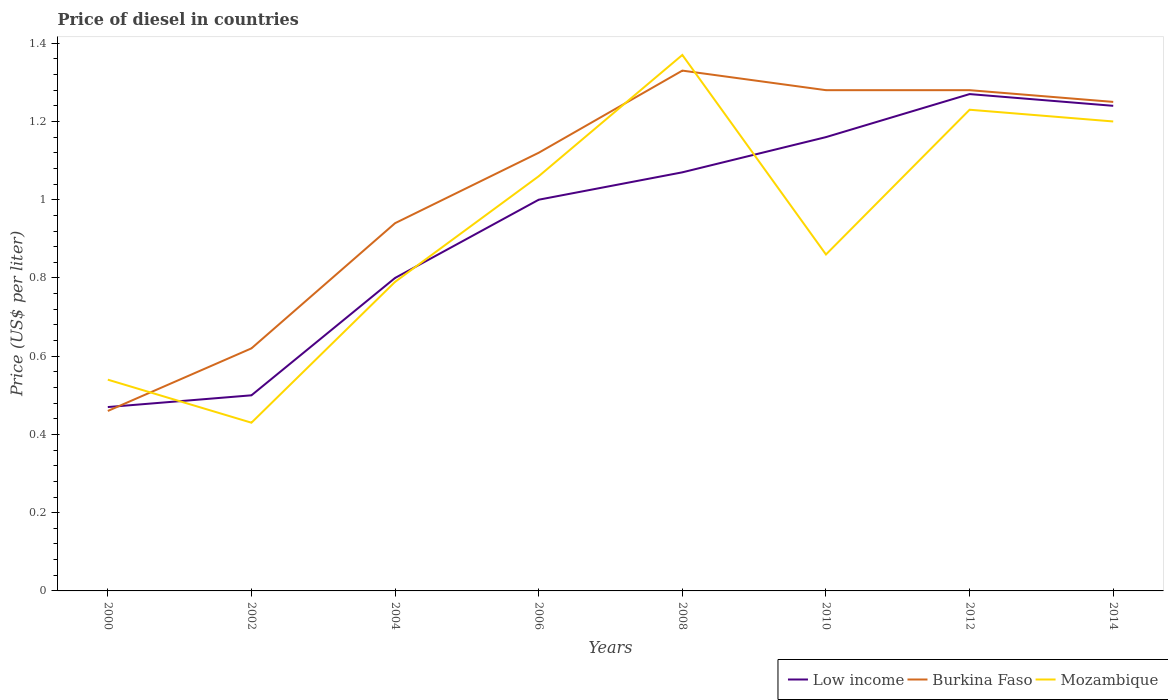How many different coloured lines are there?
Keep it short and to the point. 3. Does the line corresponding to Low income intersect with the line corresponding to Mozambique?
Your answer should be compact. Yes. Is the number of lines equal to the number of legend labels?
Your answer should be very brief. Yes. Across all years, what is the maximum price of diesel in Low income?
Provide a short and direct response. 0.47. In which year was the price of diesel in Low income maximum?
Your answer should be very brief. 2000. What is the difference between the highest and the second highest price of diesel in Mozambique?
Ensure brevity in your answer.  0.94. Is the price of diesel in Burkina Faso strictly greater than the price of diesel in Mozambique over the years?
Your response must be concise. No. How many lines are there?
Your answer should be compact. 3. What is the difference between two consecutive major ticks on the Y-axis?
Provide a succinct answer. 0.2. Does the graph contain any zero values?
Give a very brief answer. No. How many legend labels are there?
Your answer should be very brief. 3. How are the legend labels stacked?
Your answer should be compact. Horizontal. What is the title of the graph?
Provide a succinct answer. Price of diesel in countries. What is the label or title of the Y-axis?
Ensure brevity in your answer.  Price (US$ per liter). What is the Price (US$ per liter) of Low income in 2000?
Ensure brevity in your answer.  0.47. What is the Price (US$ per liter) in Burkina Faso in 2000?
Your response must be concise. 0.46. What is the Price (US$ per liter) in Mozambique in 2000?
Give a very brief answer. 0.54. What is the Price (US$ per liter) of Burkina Faso in 2002?
Give a very brief answer. 0.62. What is the Price (US$ per liter) of Mozambique in 2002?
Offer a very short reply. 0.43. What is the Price (US$ per liter) of Mozambique in 2004?
Offer a very short reply. 0.79. What is the Price (US$ per liter) of Burkina Faso in 2006?
Provide a succinct answer. 1.12. What is the Price (US$ per liter) of Mozambique in 2006?
Your answer should be compact. 1.06. What is the Price (US$ per liter) of Low income in 2008?
Offer a very short reply. 1.07. What is the Price (US$ per liter) of Burkina Faso in 2008?
Your response must be concise. 1.33. What is the Price (US$ per liter) of Mozambique in 2008?
Give a very brief answer. 1.37. What is the Price (US$ per liter) of Low income in 2010?
Keep it short and to the point. 1.16. What is the Price (US$ per liter) of Burkina Faso in 2010?
Keep it short and to the point. 1.28. What is the Price (US$ per liter) in Mozambique in 2010?
Give a very brief answer. 0.86. What is the Price (US$ per liter) in Low income in 2012?
Your answer should be compact. 1.27. What is the Price (US$ per liter) of Burkina Faso in 2012?
Provide a short and direct response. 1.28. What is the Price (US$ per liter) in Mozambique in 2012?
Provide a short and direct response. 1.23. What is the Price (US$ per liter) of Low income in 2014?
Offer a very short reply. 1.24. What is the Price (US$ per liter) in Burkina Faso in 2014?
Offer a very short reply. 1.25. What is the Price (US$ per liter) in Mozambique in 2014?
Your response must be concise. 1.2. Across all years, what is the maximum Price (US$ per liter) of Low income?
Keep it short and to the point. 1.27. Across all years, what is the maximum Price (US$ per liter) in Burkina Faso?
Your answer should be compact. 1.33. Across all years, what is the maximum Price (US$ per liter) of Mozambique?
Give a very brief answer. 1.37. Across all years, what is the minimum Price (US$ per liter) of Low income?
Offer a terse response. 0.47. Across all years, what is the minimum Price (US$ per liter) in Burkina Faso?
Provide a succinct answer. 0.46. Across all years, what is the minimum Price (US$ per liter) in Mozambique?
Keep it short and to the point. 0.43. What is the total Price (US$ per liter) of Low income in the graph?
Your response must be concise. 7.51. What is the total Price (US$ per liter) in Burkina Faso in the graph?
Give a very brief answer. 8.28. What is the total Price (US$ per liter) in Mozambique in the graph?
Keep it short and to the point. 7.48. What is the difference between the Price (US$ per liter) of Low income in 2000 and that in 2002?
Your response must be concise. -0.03. What is the difference between the Price (US$ per liter) of Burkina Faso in 2000 and that in 2002?
Offer a terse response. -0.16. What is the difference between the Price (US$ per liter) in Mozambique in 2000 and that in 2002?
Make the answer very short. 0.11. What is the difference between the Price (US$ per liter) in Low income in 2000 and that in 2004?
Provide a succinct answer. -0.33. What is the difference between the Price (US$ per liter) in Burkina Faso in 2000 and that in 2004?
Your answer should be very brief. -0.48. What is the difference between the Price (US$ per liter) of Mozambique in 2000 and that in 2004?
Make the answer very short. -0.25. What is the difference between the Price (US$ per liter) of Low income in 2000 and that in 2006?
Provide a succinct answer. -0.53. What is the difference between the Price (US$ per liter) of Burkina Faso in 2000 and that in 2006?
Offer a terse response. -0.66. What is the difference between the Price (US$ per liter) in Mozambique in 2000 and that in 2006?
Offer a very short reply. -0.52. What is the difference between the Price (US$ per liter) in Low income in 2000 and that in 2008?
Keep it short and to the point. -0.6. What is the difference between the Price (US$ per liter) of Burkina Faso in 2000 and that in 2008?
Your response must be concise. -0.87. What is the difference between the Price (US$ per liter) of Mozambique in 2000 and that in 2008?
Your response must be concise. -0.83. What is the difference between the Price (US$ per liter) in Low income in 2000 and that in 2010?
Offer a very short reply. -0.69. What is the difference between the Price (US$ per liter) of Burkina Faso in 2000 and that in 2010?
Your answer should be compact. -0.82. What is the difference between the Price (US$ per liter) of Mozambique in 2000 and that in 2010?
Your response must be concise. -0.32. What is the difference between the Price (US$ per liter) of Burkina Faso in 2000 and that in 2012?
Offer a very short reply. -0.82. What is the difference between the Price (US$ per liter) of Mozambique in 2000 and that in 2012?
Your answer should be compact. -0.69. What is the difference between the Price (US$ per liter) in Low income in 2000 and that in 2014?
Offer a very short reply. -0.77. What is the difference between the Price (US$ per liter) in Burkina Faso in 2000 and that in 2014?
Your answer should be compact. -0.79. What is the difference between the Price (US$ per liter) of Mozambique in 2000 and that in 2014?
Provide a succinct answer. -0.66. What is the difference between the Price (US$ per liter) of Low income in 2002 and that in 2004?
Make the answer very short. -0.3. What is the difference between the Price (US$ per liter) of Burkina Faso in 2002 and that in 2004?
Give a very brief answer. -0.32. What is the difference between the Price (US$ per liter) of Mozambique in 2002 and that in 2004?
Your answer should be very brief. -0.36. What is the difference between the Price (US$ per liter) of Burkina Faso in 2002 and that in 2006?
Your response must be concise. -0.5. What is the difference between the Price (US$ per liter) in Mozambique in 2002 and that in 2006?
Your answer should be compact. -0.63. What is the difference between the Price (US$ per liter) in Low income in 2002 and that in 2008?
Make the answer very short. -0.57. What is the difference between the Price (US$ per liter) in Burkina Faso in 2002 and that in 2008?
Your answer should be very brief. -0.71. What is the difference between the Price (US$ per liter) of Mozambique in 2002 and that in 2008?
Ensure brevity in your answer.  -0.94. What is the difference between the Price (US$ per liter) of Low income in 2002 and that in 2010?
Your answer should be very brief. -0.66. What is the difference between the Price (US$ per liter) of Burkina Faso in 2002 and that in 2010?
Offer a terse response. -0.66. What is the difference between the Price (US$ per liter) in Mozambique in 2002 and that in 2010?
Provide a short and direct response. -0.43. What is the difference between the Price (US$ per liter) in Low income in 2002 and that in 2012?
Your response must be concise. -0.77. What is the difference between the Price (US$ per liter) in Burkina Faso in 2002 and that in 2012?
Provide a short and direct response. -0.66. What is the difference between the Price (US$ per liter) of Low income in 2002 and that in 2014?
Make the answer very short. -0.74. What is the difference between the Price (US$ per liter) of Burkina Faso in 2002 and that in 2014?
Provide a short and direct response. -0.63. What is the difference between the Price (US$ per liter) of Mozambique in 2002 and that in 2014?
Offer a very short reply. -0.77. What is the difference between the Price (US$ per liter) of Burkina Faso in 2004 and that in 2006?
Make the answer very short. -0.18. What is the difference between the Price (US$ per liter) of Mozambique in 2004 and that in 2006?
Ensure brevity in your answer.  -0.27. What is the difference between the Price (US$ per liter) in Low income in 2004 and that in 2008?
Provide a short and direct response. -0.27. What is the difference between the Price (US$ per liter) in Burkina Faso in 2004 and that in 2008?
Provide a succinct answer. -0.39. What is the difference between the Price (US$ per liter) in Mozambique in 2004 and that in 2008?
Give a very brief answer. -0.58. What is the difference between the Price (US$ per liter) in Low income in 2004 and that in 2010?
Your response must be concise. -0.36. What is the difference between the Price (US$ per liter) in Burkina Faso in 2004 and that in 2010?
Provide a short and direct response. -0.34. What is the difference between the Price (US$ per liter) of Mozambique in 2004 and that in 2010?
Provide a succinct answer. -0.07. What is the difference between the Price (US$ per liter) in Low income in 2004 and that in 2012?
Provide a short and direct response. -0.47. What is the difference between the Price (US$ per liter) in Burkina Faso in 2004 and that in 2012?
Ensure brevity in your answer.  -0.34. What is the difference between the Price (US$ per liter) in Mozambique in 2004 and that in 2012?
Ensure brevity in your answer.  -0.44. What is the difference between the Price (US$ per liter) of Low income in 2004 and that in 2014?
Keep it short and to the point. -0.44. What is the difference between the Price (US$ per liter) in Burkina Faso in 2004 and that in 2014?
Your answer should be very brief. -0.31. What is the difference between the Price (US$ per liter) of Mozambique in 2004 and that in 2014?
Your answer should be very brief. -0.41. What is the difference between the Price (US$ per liter) of Low income in 2006 and that in 2008?
Provide a short and direct response. -0.07. What is the difference between the Price (US$ per liter) of Burkina Faso in 2006 and that in 2008?
Provide a succinct answer. -0.21. What is the difference between the Price (US$ per liter) in Mozambique in 2006 and that in 2008?
Your response must be concise. -0.31. What is the difference between the Price (US$ per liter) of Low income in 2006 and that in 2010?
Offer a terse response. -0.16. What is the difference between the Price (US$ per liter) in Burkina Faso in 2006 and that in 2010?
Your response must be concise. -0.16. What is the difference between the Price (US$ per liter) in Low income in 2006 and that in 2012?
Your answer should be compact. -0.27. What is the difference between the Price (US$ per liter) of Burkina Faso in 2006 and that in 2012?
Provide a short and direct response. -0.16. What is the difference between the Price (US$ per liter) in Mozambique in 2006 and that in 2012?
Ensure brevity in your answer.  -0.17. What is the difference between the Price (US$ per liter) of Low income in 2006 and that in 2014?
Give a very brief answer. -0.24. What is the difference between the Price (US$ per liter) of Burkina Faso in 2006 and that in 2014?
Provide a succinct answer. -0.13. What is the difference between the Price (US$ per liter) of Mozambique in 2006 and that in 2014?
Keep it short and to the point. -0.14. What is the difference between the Price (US$ per liter) of Low income in 2008 and that in 2010?
Keep it short and to the point. -0.09. What is the difference between the Price (US$ per liter) of Mozambique in 2008 and that in 2010?
Your response must be concise. 0.51. What is the difference between the Price (US$ per liter) in Burkina Faso in 2008 and that in 2012?
Offer a very short reply. 0.05. What is the difference between the Price (US$ per liter) in Mozambique in 2008 and that in 2012?
Ensure brevity in your answer.  0.14. What is the difference between the Price (US$ per liter) in Low income in 2008 and that in 2014?
Keep it short and to the point. -0.17. What is the difference between the Price (US$ per liter) in Mozambique in 2008 and that in 2014?
Your answer should be very brief. 0.17. What is the difference between the Price (US$ per liter) of Low income in 2010 and that in 2012?
Provide a short and direct response. -0.11. What is the difference between the Price (US$ per liter) in Mozambique in 2010 and that in 2012?
Offer a terse response. -0.37. What is the difference between the Price (US$ per liter) of Low income in 2010 and that in 2014?
Keep it short and to the point. -0.08. What is the difference between the Price (US$ per liter) of Burkina Faso in 2010 and that in 2014?
Your answer should be very brief. 0.03. What is the difference between the Price (US$ per liter) of Mozambique in 2010 and that in 2014?
Your answer should be compact. -0.34. What is the difference between the Price (US$ per liter) of Low income in 2012 and that in 2014?
Keep it short and to the point. 0.03. What is the difference between the Price (US$ per liter) of Burkina Faso in 2012 and that in 2014?
Make the answer very short. 0.03. What is the difference between the Price (US$ per liter) of Low income in 2000 and the Price (US$ per liter) of Mozambique in 2002?
Your response must be concise. 0.04. What is the difference between the Price (US$ per liter) in Burkina Faso in 2000 and the Price (US$ per liter) in Mozambique in 2002?
Offer a very short reply. 0.03. What is the difference between the Price (US$ per liter) of Low income in 2000 and the Price (US$ per liter) of Burkina Faso in 2004?
Give a very brief answer. -0.47. What is the difference between the Price (US$ per liter) in Low income in 2000 and the Price (US$ per liter) in Mozambique in 2004?
Ensure brevity in your answer.  -0.32. What is the difference between the Price (US$ per liter) of Burkina Faso in 2000 and the Price (US$ per liter) of Mozambique in 2004?
Offer a terse response. -0.33. What is the difference between the Price (US$ per liter) in Low income in 2000 and the Price (US$ per liter) in Burkina Faso in 2006?
Provide a short and direct response. -0.65. What is the difference between the Price (US$ per liter) of Low income in 2000 and the Price (US$ per liter) of Mozambique in 2006?
Offer a terse response. -0.59. What is the difference between the Price (US$ per liter) of Burkina Faso in 2000 and the Price (US$ per liter) of Mozambique in 2006?
Provide a short and direct response. -0.6. What is the difference between the Price (US$ per liter) in Low income in 2000 and the Price (US$ per liter) in Burkina Faso in 2008?
Provide a short and direct response. -0.86. What is the difference between the Price (US$ per liter) of Burkina Faso in 2000 and the Price (US$ per liter) of Mozambique in 2008?
Make the answer very short. -0.91. What is the difference between the Price (US$ per liter) in Low income in 2000 and the Price (US$ per liter) in Burkina Faso in 2010?
Keep it short and to the point. -0.81. What is the difference between the Price (US$ per liter) of Low income in 2000 and the Price (US$ per liter) of Mozambique in 2010?
Ensure brevity in your answer.  -0.39. What is the difference between the Price (US$ per liter) of Burkina Faso in 2000 and the Price (US$ per liter) of Mozambique in 2010?
Provide a succinct answer. -0.4. What is the difference between the Price (US$ per liter) in Low income in 2000 and the Price (US$ per liter) in Burkina Faso in 2012?
Your answer should be very brief. -0.81. What is the difference between the Price (US$ per liter) in Low income in 2000 and the Price (US$ per liter) in Mozambique in 2012?
Make the answer very short. -0.76. What is the difference between the Price (US$ per liter) in Burkina Faso in 2000 and the Price (US$ per liter) in Mozambique in 2012?
Provide a short and direct response. -0.77. What is the difference between the Price (US$ per liter) of Low income in 2000 and the Price (US$ per liter) of Burkina Faso in 2014?
Your answer should be compact. -0.78. What is the difference between the Price (US$ per liter) of Low income in 2000 and the Price (US$ per liter) of Mozambique in 2014?
Offer a terse response. -0.73. What is the difference between the Price (US$ per liter) of Burkina Faso in 2000 and the Price (US$ per liter) of Mozambique in 2014?
Offer a very short reply. -0.74. What is the difference between the Price (US$ per liter) of Low income in 2002 and the Price (US$ per liter) of Burkina Faso in 2004?
Provide a short and direct response. -0.44. What is the difference between the Price (US$ per liter) of Low income in 2002 and the Price (US$ per liter) of Mozambique in 2004?
Offer a very short reply. -0.29. What is the difference between the Price (US$ per liter) of Burkina Faso in 2002 and the Price (US$ per liter) of Mozambique in 2004?
Offer a very short reply. -0.17. What is the difference between the Price (US$ per liter) in Low income in 2002 and the Price (US$ per liter) in Burkina Faso in 2006?
Your answer should be very brief. -0.62. What is the difference between the Price (US$ per liter) in Low income in 2002 and the Price (US$ per liter) in Mozambique in 2006?
Offer a terse response. -0.56. What is the difference between the Price (US$ per liter) in Burkina Faso in 2002 and the Price (US$ per liter) in Mozambique in 2006?
Provide a short and direct response. -0.44. What is the difference between the Price (US$ per liter) in Low income in 2002 and the Price (US$ per liter) in Burkina Faso in 2008?
Ensure brevity in your answer.  -0.83. What is the difference between the Price (US$ per liter) of Low income in 2002 and the Price (US$ per liter) of Mozambique in 2008?
Your answer should be very brief. -0.87. What is the difference between the Price (US$ per liter) of Burkina Faso in 2002 and the Price (US$ per liter) of Mozambique in 2008?
Your answer should be very brief. -0.75. What is the difference between the Price (US$ per liter) in Low income in 2002 and the Price (US$ per liter) in Burkina Faso in 2010?
Your answer should be compact. -0.78. What is the difference between the Price (US$ per liter) in Low income in 2002 and the Price (US$ per liter) in Mozambique in 2010?
Provide a succinct answer. -0.36. What is the difference between the Price (US$ per liter) of Burkina Faso in 2002 and the Price (US$ per liter) of Mozambique in 2010?
Your answer should be compact. -0.24. What is the difference between the Price (US$ per liter) in Low income in 2002 and the Price (US$ per liter) in Burkina Faso in 2012?
Your answer should be very brief. -0.78. What is the difference between the Price (US$ per liter) in Low income in 2002 and the Price (US$ per liter) in Mozambique in 2012?
Offer a very short reply. -0.73. What is the difference between the Price (US$ per liter) in Burkina Faso in 2002 and the Price (US$ per liter) in Mozambique in 2012?
Offer a very short reply. -0.61. What is the difference between the Price (US$ per liter) in Low income in 2002 and the Price (US$ per liter) in Burkina Faso in 2014?
Give a very brief answer. -0.75. What is the difference between the Price (US$ per liter) of Low income in 2002 and the Price (US$ per liter) of Mozambique in 2014?
Your answer should be very brief. -0.7. What is the difference between the Price (US$ per liter) of Burkina Faso in 2002 and the Price (US$ per liter) of Mozambique in 2014?
Provide a short and direct response. -0.58. What is the difference between the Price (US$ per liter) in Low income in 2004 and the Price (US$ per liter) in Burkina Faso in 2006?
Make the answer very short. -0.32. What is the difference between the Price (US$ per liter) in Low income in 2004 and the Price (US$ per liter) in Mozambique in 2006?
Your answer should be very brief. -0.26. What is the difference between the Price (US$ per liter) in Burkina Faso in 2004 and the Price (US$ per liter) in Mozambique in 2006?
Offer a very short reply. -0.12. What is the difference between the Price (US$ per liter) in Low income in 2004 and the Price (US$ per liter) in Burkina Faso in 2008?
Ensure brevity in your answer.  -0.53. What is the difference between the Price (US$ per liter) in Low income in 2004 and the Price (US$ per liter) in Mozambique in 2008?
Keep it short and to the point. -0.57. What is the difference between the Price (US$ per liter) in Burkina Faso in 2004 and the Price (US$ per liter) in Mozambique in 2008?
Provide a short and direct response. -0.43. What is the difference between the Price (US$ per liter) in Low income in 2004 and the Price (US$ per liter) in Burkina Faso in 2010?
Provide a short and direct response. -0.48. What is the difference between the Price (US$ per liter) of Low income in 2004 and the Price (US$ per liter) of Mozambique in 2010?
Your response must be concise. -0.06. What is the difference between the Price (US$ per liter) of Burkina Faso in 2004 and the Price (US$ per liter) of Mozambique in 2010?
Your answer should be very brief. 0.08. What is the difference between the Price (US$ per liter) of Low income in 2004 and the Price (US$ per liter) of Burkina Faso in 2012?
Offer a terse response. -0.48. What is the difference between the Price (US$ per liter) in Low income in 2004 and the Price (US$ per liter) in Mozambique in 2012?
Provide a short and direct response. -0.43. What is the difference between the Price (US$ per liter) in Burkina Faso in 2004 and the Price (US$ per liter) in Mozambique in 2012?
Offer a terse response. -0.29. What is the difference between the Price (US$ per liter) in Low income in 2004 and the Price (US$ per liter) in Burkina Faso in 2014?
Your answer should be compact. -0.45. What is the difference between the Price (US$ per liter) of Low income in 2004 and the Price (US$ per liter) of Mozambique in 2014?
Provide a short and direct response. -0.4. What is the difference between the Price (US$ per liter) in Burkina Faso in 2004 and the Price (US$ per liter) in Mozambique in 2014?
Keep it short and to the point. -0.26. What is the difference between the Price (US$ per liter) of Low income in 2006 and the Price (US$ per liter) of Burkina Faso in 2008?
Offer a very short reply. -0.33. What is the difference between the Price (US$ per liter) in Low income in 2006 and the Price (US$ per liter) in Mozambique in 2008?
Keep it short and to the point. -0.37. What is the difference between the Price (US$ per liter) of Low income in 2006 and the Price (US$ per liter) of Burkina Faso in 2010?
Keep it short and to the point. -0.28. What is the difference between the Price (US$ per liter) of Low income in 2006 and the Price (US$ per liter) of Mozambique in 2010?
Make the answer very short. 0.14. What is the difference between the Price (US$ per liter) of Burkina Faso in 2006 and the Price (US$ per liter) of Mozambique in 2010?
Offer a very short reply. 0.26. What is the difference between the Price (US$ per liter) of Low income in 2006 and the Price (US$ per liter) of Burkina Faso in 2012?
Ensure brevity in your answer.  -0.28. What is the difference between the Price (US$ per liter) in Low income in 2006 and the Price (US$ per liter) in Mozambique in 2012?
Provide a short and direct response. -0.23. What is the difference between the Price (US$ per liter) in Burkina Faso in 2006 and the Price (US$ per liter) in Mozambique in 2012?
Provide a succinct answer. -0.11. What is the difference between the Price (US$ per liter) in Low income in 2006 and the Price (US$ per liter) in Mozambique in 2014?
Your answer should be compact. -0.2. What is the difference between the Price (US$ per liter) of Burkina Faso in 2006 and the Price (US$ per liter) of Mozambique in 2014?
Keep it short and to the point. -0.08. What is the difference between the Price (US$ per liter) of Low income in 2008 and the Price (US$ per liter) of Burkina Faso in 2010?
Offer a terse response. -0.21. What is the difference between the Price (US$ per liter) in Low income in 2008 and the Price (US$ per liter) in Mozambique in 2010?
Give a very brief answer. 0.21. What is the difference between the Price (US$ per liter) of Burkina Faso in 2008 and the Price (US$ per liter) of Mozambique in 2010?
Your response must be concise. 0.47. What is the difference between the Price (US$ per liter) of Low income in 2008 and the Price (US$ per liter) of Burkina Faso in 2012?
Offer a very short reply. -0.21. What is the difference between the Price (US$ per liter) of Low income in 2008 and the Price (US$ per liter) of Mozambique in 2012?
Ensure brevity in your answer.  -0.16. What is the difference between the Price (US$ per liter) of Burkina Faso in 2008 and the Price (US$ per liter) of Mozambique in 2012?
Your answer should be compact. 0.1. What is the difference between the Price (US$ per liter) of Low income in 2008 and the Price (US$ per liter) of Burkina Faso in 2014?
Offer a terse response. -0.18. What is the difference between the Price (US$ per liter) in Low income in 2008 and the Price (US$ per liter) in Mozambique in 2014?
Make the answer very short. -0.13. What is the difference between the Price (US$ per liter) in Burkina Faso in 2008 and the Price (US$ per liter) in Mozambique in 2014?
Provide a short and direct response. 0.13. What is the difference between the Price (US$ per liter) in Low income in 2010 and the Price (US$ per liter) in Burkina Faso in 2012?
Ensure brevity in your answer.  -0.12. What is the difference between the Price (US$ per liter) of Low income in 2010 and the Price (US$ per liter) of Mozambique in 2012?
Your response must be concise. -0.07. What is the difference between the Price (US$ per liter) in Burkina Faso in 2010 and the Price (US$ per liter) in Mozambique in 2012?
Provide a short and direct response. 0.05. What is the difference between the Price (US$ per liter) in Low income in 2010 and the Price (US$ per liter) in Burkina Faso in 2014?
Ensure brevity in your answer.  -0.09. What is the difference between the Price (US$ per liter) in Low income in 2010 and the Price (US$ per liter) in Mozambique in 2014?
Give a very brief answer. -0.04. What is the difference between the Price (US$ per liter) of Burkina Faso in 2010 and the Price (US$ per liter) of Mozambique in 2014?
Keep it short and to the point. 0.08. What is the difference between the Price (US$ per liter) of Low income in 2012 and the Price (US$ per liter) of Burkina Faso in 2014?
Your answer should be very brief. 0.02. What is the difference between the Price (US$ per liter) of Low income in 2012 and the Price (US$ per liter) of Mozambique in 2014?
Make the answer very short. 0.07. What is the average Price (US$ per liter) of Low income per year?
Provide a succinct answer. 0.94. What is the average Price (US$ per liter) in Burkina Faso per year?
Your answer should be compact. 1.03. What is the average Price (US$ per liter) of Mozambique per year?
Keep it short and to the point. 0.94. In the year 2000, what is the difference between the Price (US$ per liter) in Low income and Price (US$ per liter) in Mozambique?
Your answer should be very brief. -0.07. In the year 2000, what is the difference between the Price (US$ per liter) in Burkina Faso and Price (US$ per liter) in Mozambique?
Your answer should be very brief. -0.08. In the year 2002, what is the difference between the Price (US$ per liter) in Low income and Price (US$ per liter) in Burkina Faso?
Offer a very short reply. -0.12. In the year 2002, what is the difference between the Price (US$ per liter) in Low income and Price (US$ per liter) in Mozambique?
Provide a short and direct response. 0.07. In the year 2002, what is the difference between the Price (US$ per liter) of Burkina Faso and Price (US$ per liter) of Mozambique?
Provide a succinct answer. 0.19. In the year 2004, what is the difference between the Price (US$ per liter) in Low income and Price (US$ per liter) in Burkina Faso?
Your response must be concise. -0.14. In the year 2004, what is the difference between the Price (US$ per liter) in Burkina Faso and Price (US$ per liter) in Mozambique?
Offer a very short reply. 0.15. In the year 2006, what is the difference between the Price (US$ per liter) in Low income and Price (US$ per liter) in Burkina Faso?
Keep it short and to the point. -0.12. In the year 2006, what is the difference between the Price (US$ per liter) in Low income and Price (US$ per liter) in Mozambique?
Offer a terse response. -0.06. In the year 2006, what is the difference between the Price (US$ per liter) in Burkina Faso and Price (US$ per liter) in Mozambique?
Make the answer very short. 0.06. In the year 2008, what is the difference between the Price (US$ per liter) in Low income and Price (US$ per liter) in Burkina Faso?
Make the answer very short. -0.26. In the year 2008, what is the difference between the Price (US$ per liter) of Low income and Price (US$ per liter) of Mozambique?
Make the answer very short. -0.3. In the year 2008, what is the difference between the Price (US$ per liter) in Burkina Faso and Price (US$ per liter) in Mozambique?
Give a very brief answer. -0.04. In the year 2010, what is the difference between the Price (US$ per liter) in Low income and Price (US$ per liter) in Burkina Faso?
Offer a terse response. -0.12. In the year 2010, what is the difference between the Price (US$ per liter) in Low income and Price (US$ per liter) in Mozambique?
Your response must be concise. 0.3. In the year 2010, what is the difference between the Price (US$ per liter) of Burkina Faso and Price (US$ per liter) of Mozambique?
Your answer should be compact. 0.42. In the year 2012, what is the difference between the Price (US$ per liter) of Low income and Price (US$ per liter) of Burkina Faso?
Offer a very short reply. -0.01. In the year 2014, what is the difference between the Price (US$ per liter) in Low income and Price (US$ per liter) in Burkina Faso?
Your answer should be compact. -0.01. In the year 2014, what is the difference between the Price (US$ per liter) in Low income and Price (US$ per liter) in Mozambique?
Offer a very short reply. 0.04. What is the ratio of the Price (US$ per liter) of Burkina Faso in 2000 to that in 2002?
Make the answer very short. 0.74. What is the ratio of the Price (US$ per liter) of Mozambique in 2000 to that in 2002?
Offer a terse response. 1.26. What is the ratio of the Price (US$ per liter) in Low income in 2000 to that in 2004?
Keep it short and to the point. 0.59. What is the ratio of the Price (US$ per liter) of Burkina Faso in 2000 to that in 2004?
Keep it short and to the point. 0.49. What is the ratio of the Price (US$ per liter) of Mozambique in 2000 to that in 2004?
Your answer should be very brief. 0.68. What is the ratio of the Price (US$ per liter) in Low income in 2000 to that in 2006?
Provide a succinct answer. 0.47. What is the ratio of the Price (US$ per liter) in Burkina Faso in 2000 to that in 2006?
Offer a very short reply. 0.41. What is the ratio of the Price (US$ per liter) of Mozambique in 2000 to that in 2006?
Make the answer very short. 0.51. What is the ratio of the Price (US$ per liter) of Low income in 2000 to that in 2008?
Offer a terse response. 0.44. What is the ratio of the Price (US$ per liter) in Burkina Faso in 2000 to that in 2008?
Give a very brief answer. 0.35. What is the ratio of the Price (US$ per liter) of Mozambique in 2000 to that in 2008?
Provide a succinct answer. 0.39. What is the ratio of the Price (US$ per liter) in Low income in 2000 to that in 2010?
Offer a very short reply. 0.41. What is the ratio of the Price (US$ per liter) in Burkina Faso in 2000 to that in 2010?
Your response must be concise. 0.36. What is the ratio of the Price (US$ per liter) of Mozambique in 2000 to that in 2010?
Ensure brevity in your answer.  0.63. What is the ratio of the Price (US$ per liter) of Low income in 2000 to that in 2012?
Offer a terse response. 0.37. What is the ratio of the Price (US$ per liter) of Burkina Faso in 2000 to that in 2012?
Offer a terse response. 0.36. What is the ratio of the Price (US$ per liter) of Mozambique in 2000 to that in 2012?
Your response must be concise. 0.44. What is the ratio of the Price (US$ per liter) of Low income in 2000 to that in 2014?
Offer a very short reply. 0.38. What is the ratio of the Price (US$ per liter) in Burkina Faso in 2000 to that in 2014?
Your response must be concise. 0.37. What is the ratio of the Price (US$ per liter) of Mozambique in 2000 to that in 2014?
Offer a terse response. 0.45. What is the ratio of the Price (US$ per liter) of Low income in 2002 to that in 2004?
Ensure brevity in your answer.  0.62. What is the ratio of the Price (US$ per liter) in Burkina Faso in 2002 to that in 2004?
Offer a very short reply. 0.66. What is the ratio of the Price (US$ per liter) of Mozambique in 2002 to that in 2004?
Your answer should be very brief. 0.54. What is the ratio of the Price (US$ per liter) in Low income in 2002 to that in 2006?
Provide a short and direct response. 0.5. What is the ratio of the Price (US$ per liter) in Burkina Faso in 2002 to that in 2006?
Offer a very short reply. 0.55. What is the ratio of the Price (US$ per liter) in Mozambique in 2002 to that in 2006?
Make the answer very short. 0.41. What is the ratio of the Price (US$ per liter) of Low income in 2002 to that in 2008?
Give a very brief answer. 0.47. What is the ratio of the Price (US$ per liter) in Burkina Faso in 2002 to that in 2008?
Give a very brief answer. 0.47. What is the ratio of the Price (US$ per liter) in Mozambique in 2002 to that in 2008?
Give a very brief answer. 0.31. What is the ratio of the Price (US$ per liter) in Low income in 2002 to that in 2010?
Your response must be concise. 0.43. What is the ratio of the Price (US$ per liter) of Burkina Faso in 2002 to that in 2010?
Offer a very short reply. 0.48. What is the ratio of the Price (US$ per liter) of Mozambique in 2002 to that in 2010?
Offer a very short reply. 0.5. What is the ratio of the Price (US$ per liter) of Low income in 2002 to that in 2012?
Provide a short and direct response. 0.39. What is the ratio of the Price (US$ per liter) in Burkina Faso in 2002 to that in 2012?
Your answer should be compact. 0.48. What is the ratio of the Price (US$ per liter) of Mozambique in 2002 to that in 2012?
Your answer should be compact. 0.35. What is the ratio of the Price (US$ per liter) in Low income in 2002 to that in 2014?
Provide a short and direct response. 0.4. What is the ratio of the Price (US$ per liter) in Burkina Faso in 2002 to that in 2014?
Offer a very short reply. 0.5. What is the ratio of the Price (US$ per liter) in Mozambique in 2002 to that in 2014?
Your answer should be compact. 0.36. What is the ratio of the Price (US$ per liter) in Burkina Faso in 2004 to that in 2006?
Your response must be concise. 0.84. What is the ratio of the Price (US$ per liter) of Mozambique in 2004 to that in 2006?
Ensure brevity in your answer.  0.75. What is the ratio of the Price (US$ per liter) of Low income in 2004 to that in 2008?
Offer a terse response. 0.75. What is the ratio of the Price (US$ per liter) in Burkina Faso in 2004 to that in 2008?
Offer a very short reply. 0.71. What is the ratio of the Price (US$ per liter) of Mozambique in 2004 to that in 2008?
Offer a very short reply. 0.58. What is the ratio of the Price (US$ per liter) in Low income in 2004 to that in 2010?
Make the answer very short. 0.69. What is the ratio of the Price (US$ per liter) of Burkina Faso in 2004 to that in 2010?
Make the answer very short. 0.73. What is the ratio of the Price (US$ per liter) in Mozambique in 2004 to that in 2010?
Offer a very short reply. 0.92. What is the ratio of the Price (US$ per liter) in Low income in 2004 to that in 2012?
Make the answer very short. 0.63. What is the ratio of the Price (US$ per liter) in Burkina Faso in 2004 to that in 2012?
Offer a terse response. 0.73. What is the ratio of the Price (US$ per liter) of Mozambique in 2004 to that in 2012?
Make the answer very short. 0.64. What is the ratio of the Price (US$ per liter) in Low income in 2004 to that in 2014?
Make the answer very short. 0.65. What is the ratio of the Price (US$ per liter) of Burkina Faso in 2004 to that in 2014?
Ensure brevity in your answer.  0.75. What is the ratio of the Price (US$ per liter) in Mozambique in 2004 to that in 2014?
Ensure brevity in your answer.  0.66. What is the ratio of the Price (US$ per liter) of Low income in 2006 to that in 2008?
Make the answer very short. 0.93. What is the ratio of the Price (US$ per liter) of Burkina Faso in 2006 to that in 2008?
Provide a short and direct response. 0.84. What is the ratio of the Price (US$ per liter) in Mozambique in 2006 to that in 2008?
Ensure brevity in your answer.  0.77. What is the ratio of the Price (US$ per liter) in Low income in 2006 to that in 2010?
Your answer should be compact. 0.86. What is the ratio of the Price (US$ per liter) of Mozambique in 2006 to that in 2010?
Make the answer very short. 1.23. What is the ratio of the Price (US$ per liter) of Low income in 2006 to that in 2012?
Your answer should be compact. 0.79. What is the ratio of the Price (US$ per liter) in Mozambique in 2006 to that in 2012?
Provide a short and direct response. 0.86. What is the ratio of the Price (US$ per liter) in Low income in 2006 to that in 2014?
Offer a very short reply. 0.81. What is the ratio of the Price (US$ per liter) of Burkina Faso in 2006 to that in 2014?
Provide a short and direct response. 0.9. What is the ratio of the Price (US$ per liter) of Mozambique in 2006 to that in 2014?
Keep it short and to the point. 0.88. What is the ratio of the Price (US$ per liter) in Low income in 2008 to that in 2010?
Give a very brief answer. 0.92. What is the ratio of the Price (US$ per liter) in Burkina Faso in 2008 to that in 2010?
Keep it short and to the point. 1.04. What is the ratio of the Price (US$ per liter) of Mozambique in 2008 to that in 2010?
Make the answer very short. 1.59. What is the ratio of the Price (US$ per liter) of Low income in 2008 to that in 2012?
Ensure brevity in your answer.  0.84. What is the ratio of the Price (US$ per liter) in Burkina Faso in 2008 to that in 2012?
Offer a very short reply. 1.04. What is the ratio of the Price (US$ per liter) in Mozambique in 2008 to that in 2012?
Provide a short and direct response. 1.11. What is the ratio of the Price (US$ per liter) in Low income in 2008 to that in 2014?
Your answer should be very brief. 0.86. What is the ratio of the Price (US$ per liter) in Burkina Faso in 2008 to that in 2014?
Ensure brevity in your answer.  1.06. What is the ratio of the Price (US$ per liter) of Mozambique in 2008 to that in 2014?
Give a very brief answer. 1.14. What is the ratio of the Price (US$ per liter) of Low income in 2010 to that in 2012?
Keep it short and to the point. 0.91. What is the ratio of the Price (US$ per liter) of Mozambique in 2010 to that in 2012?
Ensure brevity in your answer.  0.7. What is the ratio of the Price (US$ per liter) in Low income in 2010 to that in 2014?
Offer a terse response. 0.94. What is the ratio of the Price (US$ per liter) of Burkina Faso in 2010 to that in 2014?
Your answer should be compact. 1.02. What is the ratio of the Price (US$ per liter) in Mozambique in 2010 to that in 2014?
Keep it short and to the point. 0.72. What is the ratio of the Price (US$ per liter) of Low income in 2012 to that in 2014?
Provide a succinct answer. 1.02. What is the difference between the highest and the second highest Price (US$ per liter) in Low income?
Ensure brevity in your answer.  0.03. What is the difference between the highest and the second highest Price (US$ per liter) in Mozambique?
Your response must be concise. 0.14. What is the difference between the highest and the lowest Price (US$ per liter) of Low income?
Provide a short and direct response. 0.8. What is the difference between the highest and the lowest Price (US$ per liter) in Burkina Faso?
Keep it short and to the point. 0.87. 